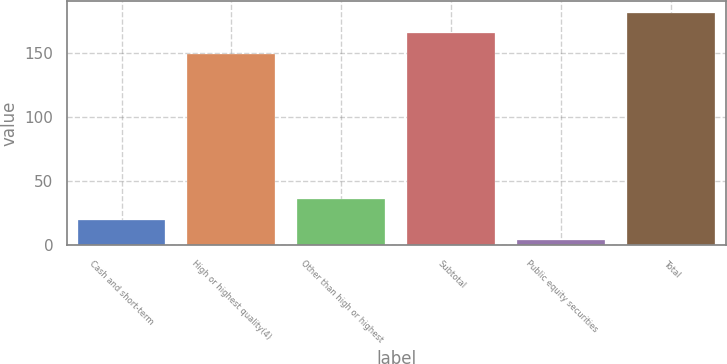<chart> <loc_0><loc_0><loc_500><loc_500><bar_chart><fcel>Cash and short-term<fcel>High or highest quality(4)<fcel>Other than high or highest<fcel>Subtotal<fcel>Public equity securities<fcel>Total<nl><fcel>19.94<fcel>149.1<fcel>35.88<fcel>165.04<fcel>4<fcel>180.98<nl></chart> 